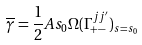<formula> <loc_0><loc_0><loc_500><loc_500>\overline { \gamma } = \frac { 1 } { 2 } A s _ { 0 } \Omega ( \Gamma _ { + - } ^ { j j ^ { \prime } } ) _ { s = s _ { 0 } }</formula> 